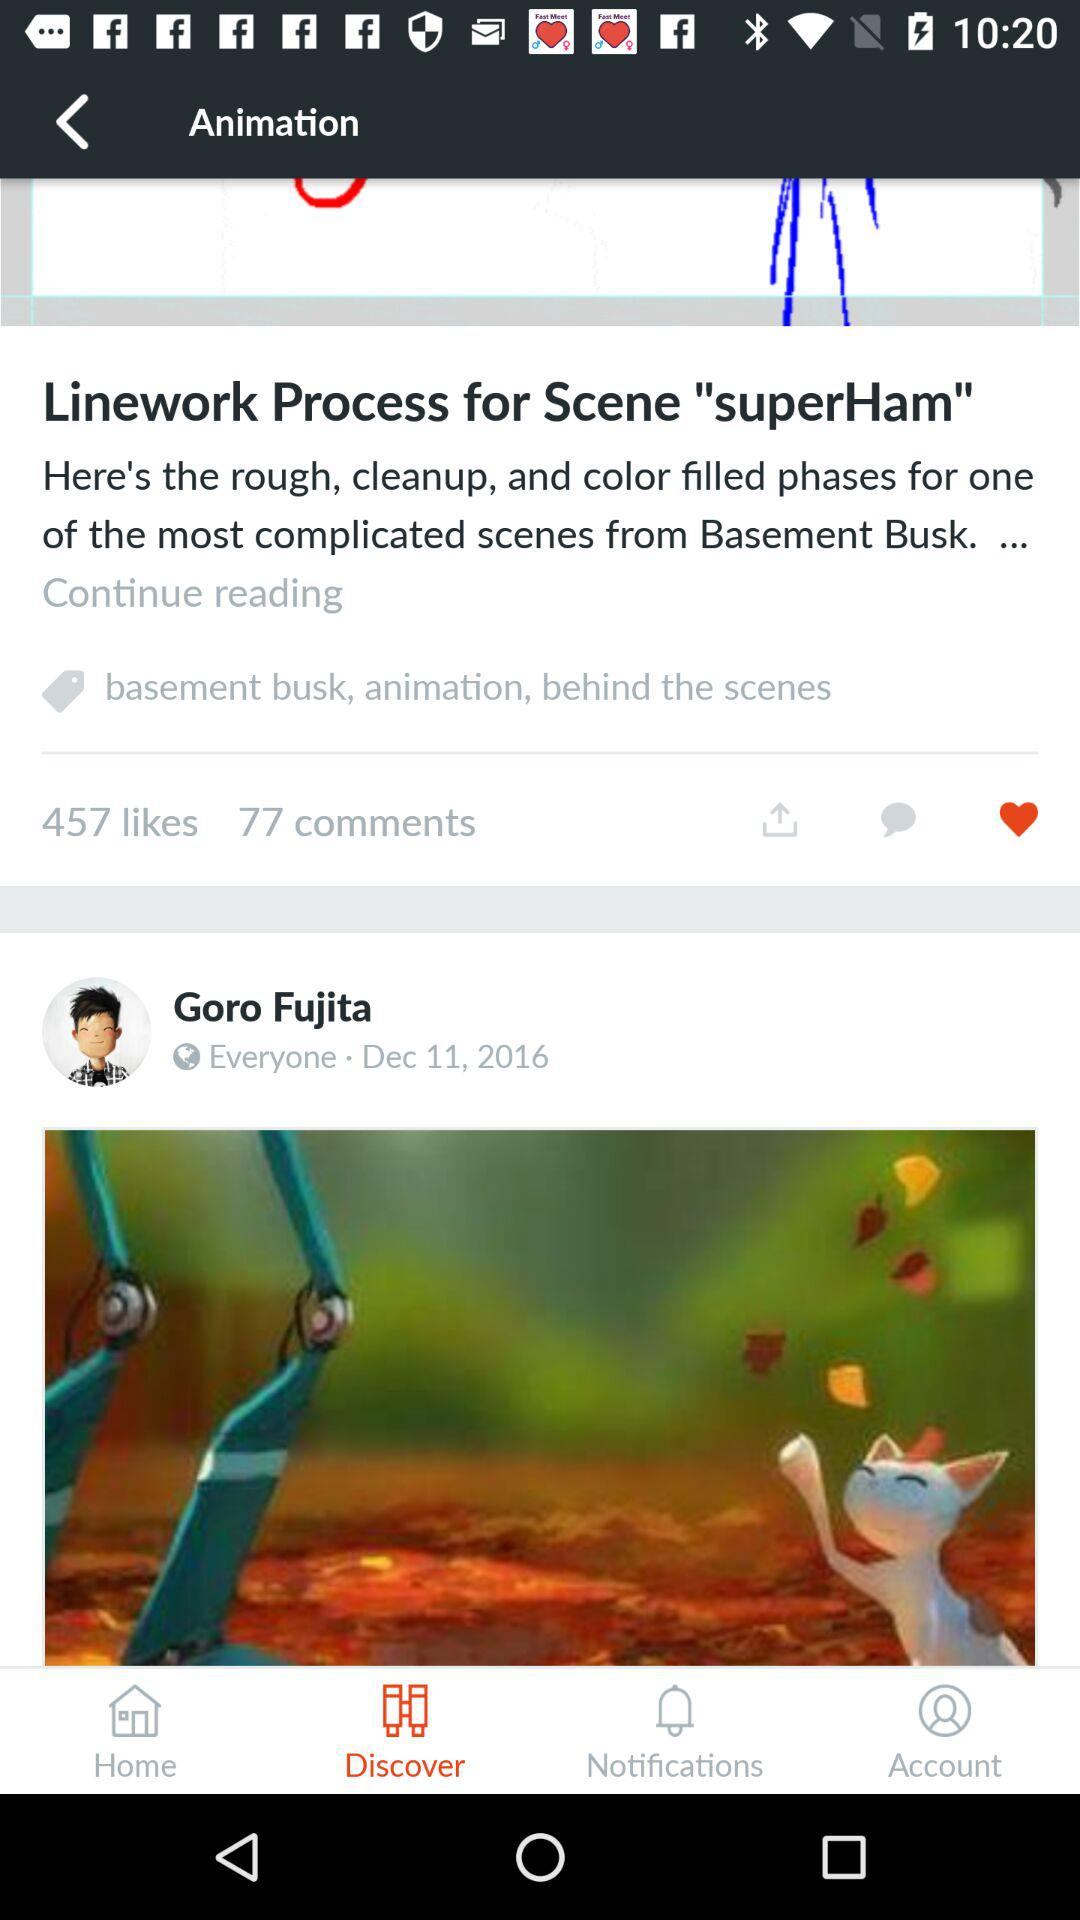How many likes of the "superHam" post? There are 457 likes. 